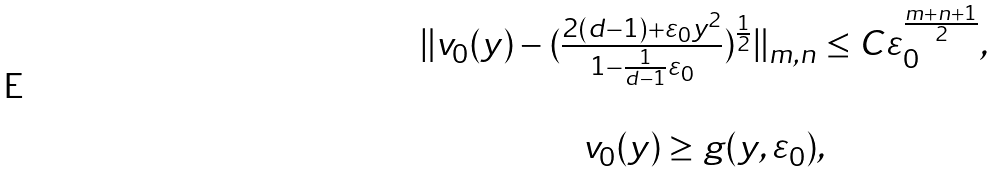<formula> <loc_0><loc_0><loc_500><loc_500>\begin{array} { c c c } & & \| v _ { 0 } ( y ) - ( \frac { 2 ( d - 1 ) + \varepsilon _ { 0 } y ^ { 2 } } { 1 - \frac { 1 } { d - 1 } \varepsilon _ { 0 } } ) ^ { \frac { 1 } { 2 } } \| _ { m , n } \leq C \varepsilon _ { 0 } ^ { \frac { m + n + 1 } { 2 } } , \\ & & \\ & & v _ { 0 } ( y ) \geq g ( y , \varepsilon _ { 0 } ) , \end{array}</formula> 